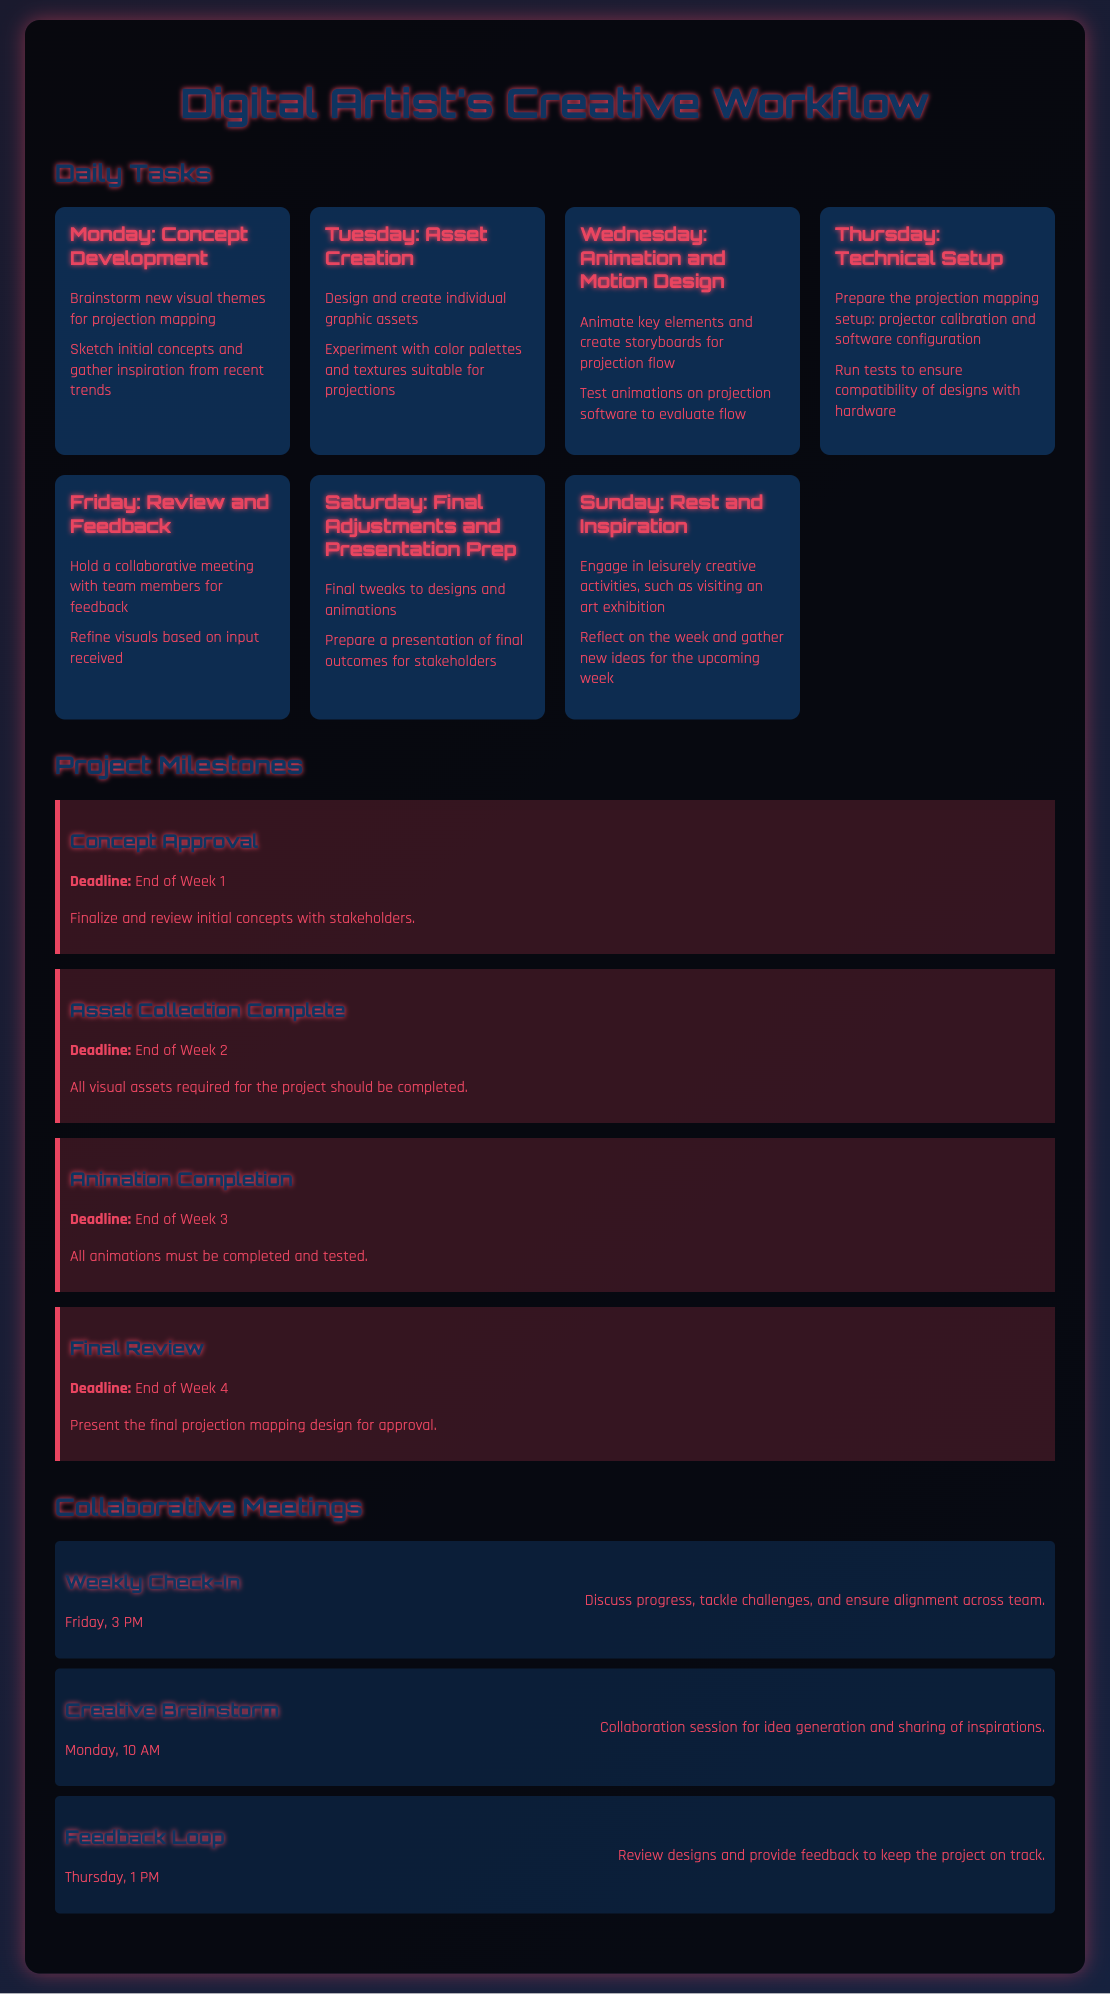what is the first daily task of the week? The first daily task in the schedule is "Concept Development," which occurs on Monday.
Answer: Concept Development what day is allocated for asset creation? The day dedicated to asset creation in the workflow is Tuesday.
Answer: Tuesday what is the deadline for Concept Approval? This milestone's deadline is specified as the end of Week 1.
Answer: End of Week 1 how many collaborative meetings are scheduled? The document outlines three collaborative meetings throughout the week.
Answer: Three what is the focus of the meeting on Monday at 10 AM? This meeting is designated as a "Creative Brainstorm" session for idea generation.
Answer: Creative Brainstorm which day involves reviewing designs and providing feedback? The design review and feedback session is scheduled for Thursday.
Answer: Thursday what is the purpose of the stand-up meeting on Friday? The purpose of the weekly check-in meeting is to discuss progress and tackle challenges.
Answer: Discuss progress how many tasks are listed for Sunday? There are two tasks outlined for Sunday in the workflow schedule.
Answer: Two what milestone is set for the end of Week 4? The final milestone outlined is the "Final Review" for approval of designs.
Answer: Final Review 